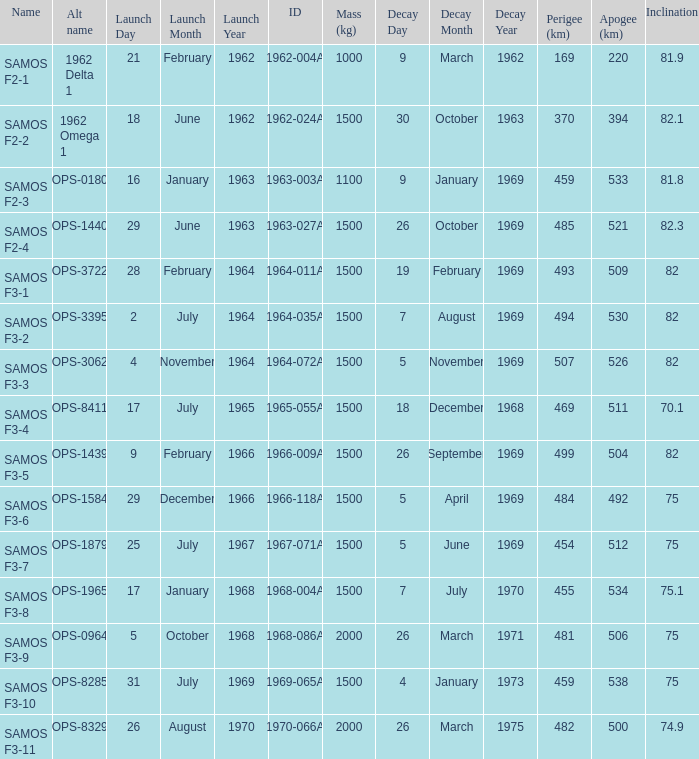How many alt names does 1964-011a have? 1.0. 